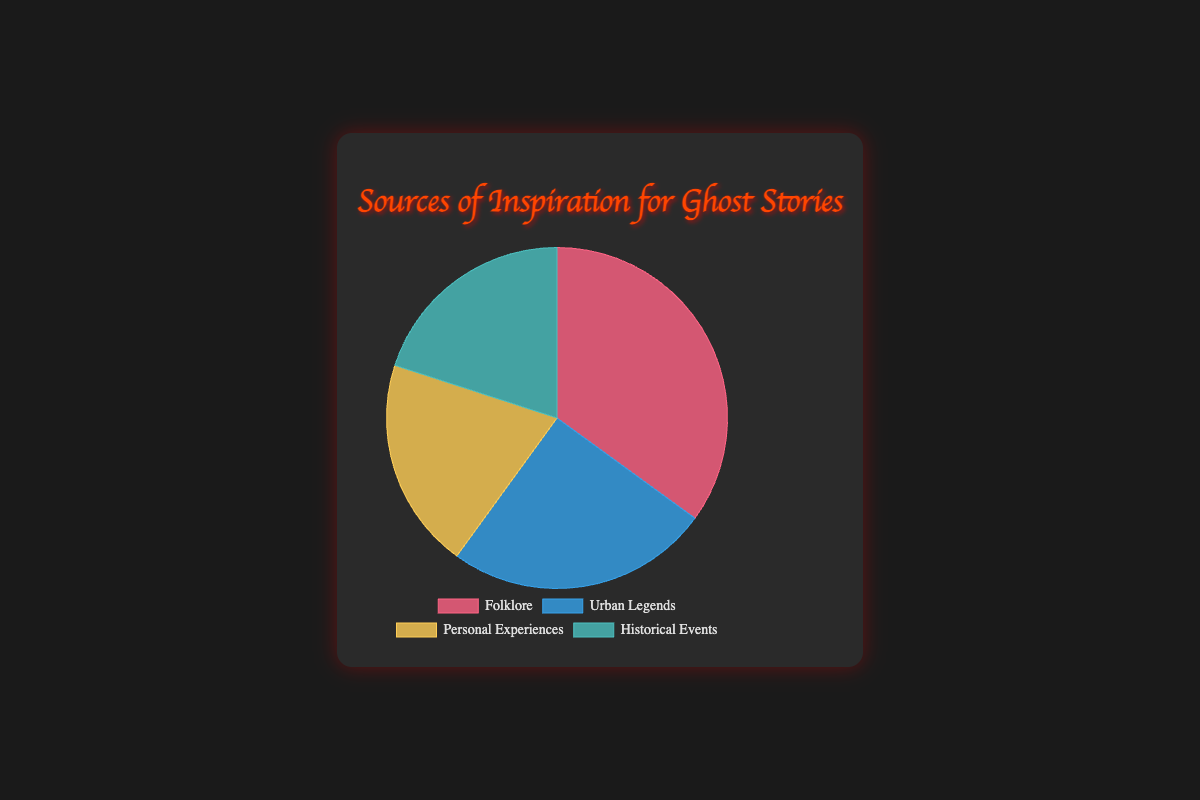What is the largest source of inspiration shown in the pie chart? The pie chart shows the percentage breakdown of different sources of inspiration. By looking at the segment sizes, we see that "Folklore" occupies the largest segment.
Answer: Folklore Which two sources of inspiration have equal representation? By examining the pie chart segments and their corresponding percentage labels, we see that both "Personal Experiences" and "Historical Events" have the same percentage representation of 20%.
Answer: Personal Experiences and Historical Events What is the total percentage of inspiration sources attributed to modern or contemporary themes? Sum the percentages of "Urban Legends" and "Personal Experiences" as they represent modern or contemporary themes: 25% (Urban Legends) + 20% (Personal Experiences) = 45%.
Answer: 45% Which color represents the "Urban Legends" section? By referring to the visual color coding in the pie chart legend, "Urban Legends" is represented by the color blue.
Answer: Blue What is the difference in percentage between the largest and smallest sources of inspiration? The largest source is "Folklore" at 35%, and the smallest is both "Personal Experiences" and "Historical Events" at 20%. Difference = 35% - 20% = 15%.
Answer: 15% How many percentage points more does "Folklore" have compared to "Urban Legends"? Subtract the percentage of "Urban Legends" from "Folklore": 35% (Folklore) - 25% (Urban Legends) = 10%.
Answer: 10% Which source of inspiration has the second largest share in the pie chart? By examining the pie chart, "Urban Legends" has the second largest share at 25%.
Answer: Urban Legends If the "Personal Experiences" segment were to increase by 10%, which source would have the smallest share? Adding 10% to "Personal Experiences" gives it a total of 30%. This is larger than "Urban Legends" and "Historical Events" at their current percentages. Therefore, "Historical Events" (20%) would be the smallest.
Answer: Historical Events What combined percentage do "Historical Events" and "Urban Legends" constitute? Add the percentages of "Historical Events" and "Urban Legends": 20% (Historical Events) + 25% (Urban Legends) = 45%.
Answer: 45% Which segment in the pie chart is represented by the green color? Referring to the color legend of the pie chart, the green segment represents "Historical Events".
Answer: Historical Events 